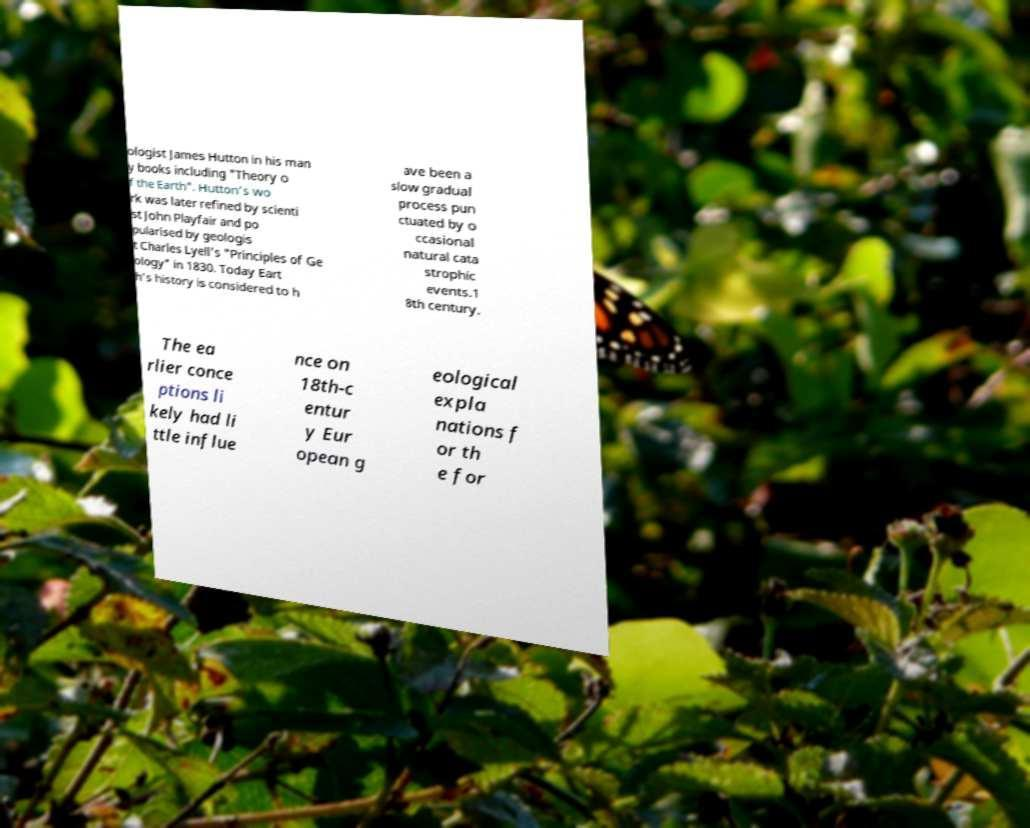Please identify and transcribe the text found in this image. ologist James Hutton in his man y books including "Theory o f the Earth". Hutton's wo rk was later refined by scienti st John Playfair and po pularised by geologis t Charles Lyell's "Principles of Ge ology" in 1830. Today Eart h's history is considered to h ave been a slow gradual process pun ctuated by o ccasional natural cata strophic events.1 8th century. The ea rlier conce ptions li kely had li ttle influe nce on 18th-c entur y Eur opean g eological expla nations f or th e for 